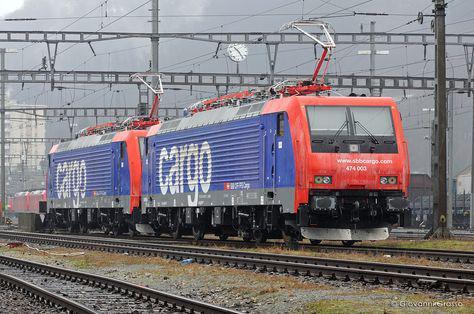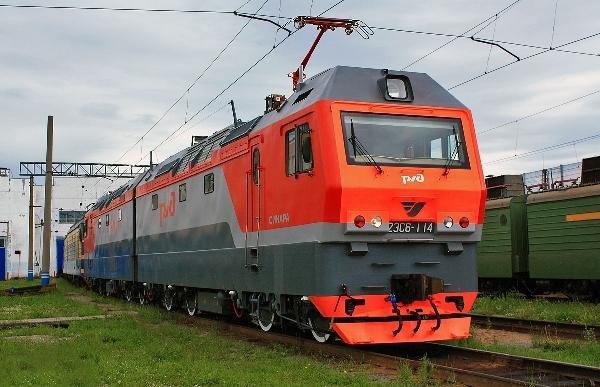The first image is the image on the left, the second image is the image on the right. Given the left and right images, does the statement "There is exactly one power pole in the image on the left" hold true? Answer yes or no. No. The first image is the image on the left, the second image is the image on the right. Analyze the images presented: Is the assertion "Trains in right and left images are true red and face different directions." valid? Answer yes or no. No. 